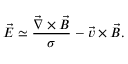<formula> <loc_0><loc_0><loc_500><loc_500>\vec { E } \simeq \frac { \vec { \nabla } \times \vec { B } } { \sigma } - \vec { v } \times \vec { B } .</formula> 